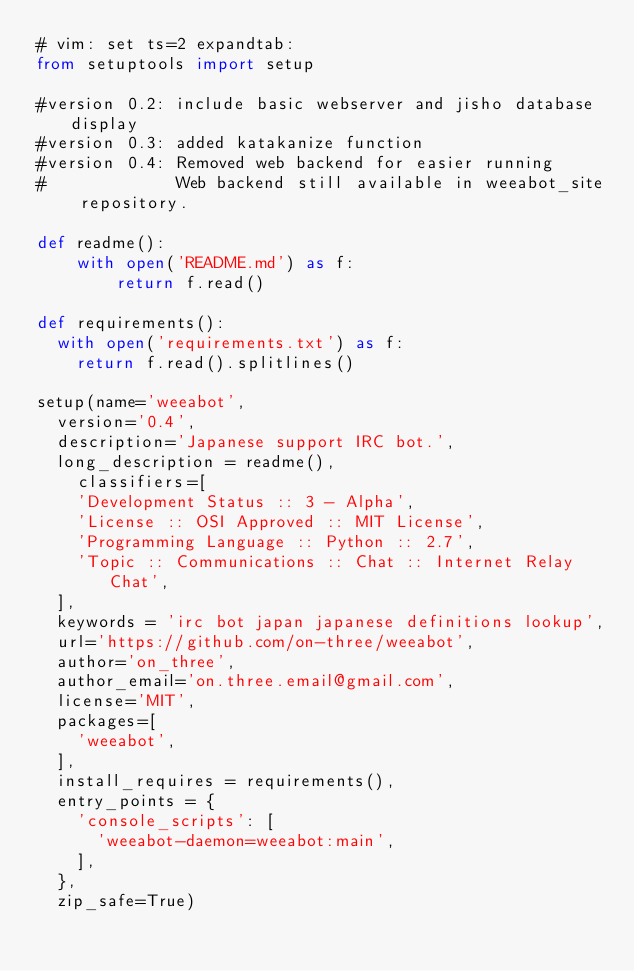<code> <loc_0><loc_0><loc_500><loc_500><_Python_># vim: set ts=2 expandtab:
from setuptools import setup

#version 0.2: include basic webserver and jisho database display
#version 0.3: added katakanize function
#version 0.4: Removed web backend for easier running
#             Web backend still available in weeabot_site repository.

def readme():
    with open('README.md') as f:
        return f.read()

def requirements():
  with open('requirements.txt') as f:
    return f.read().splitlines()

setup(name='weeabot',
  version='0.4',
  description='Japanese support IRC bot.',
  long_description = readme(),
	classifiers=[
    'Development Status :: 3 - Alpha',
    'License :: OSI Approved :: MIT License',
    'Programming Language :: Python :: 2.7',
    'Topic :: Communications :: Chat :: Internet Relay Chat',
  ],
  keywords = 'irc bot japan japanese definitions lookup',
  url='https://github.com/on-three/weeabot',
  author='on_three',
  author_email='on.three.email@gmail.com',
  license='MIT',
  packages=[
    'weeabot',
  ],
  install_requires = requirements(),
  entry_points = {
    'console_scripts': [
      'weeabot-daemon=weeabot:main',
    ],
  },
  zip_safe=True)
</code> 